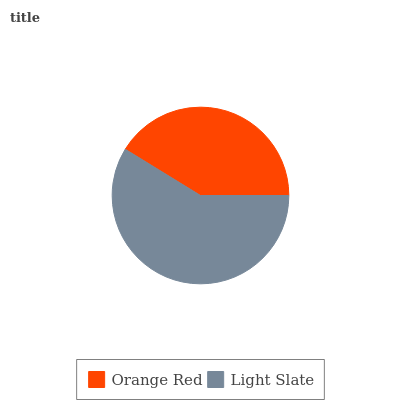Is Orange Red the minimum?
Answer yes or no. Yes. Is Light Slate the maximum?
Answer yes or no. Yes. Is Light Slate the minimum?
Answer yes or no. No. Is Light Slate greater than Orange Red?
Answer yes or no. Yes. Is Orange Red less than Light Slate?
Answer yes or no. Yes. Is Orange Red greater than Light Slate?
Answer yes or no. No. Is Light Slate less than Orange Red?
Answer yes or no. No. Is Light Slate the high median?
Answer yes or no. Yes. Is Orange Red the low median?
Answer yes or no. Yes. Is Orange Red the high median?
Answer yes or no. No. Is Light Slate the low median?
Answer yes or no. No. 